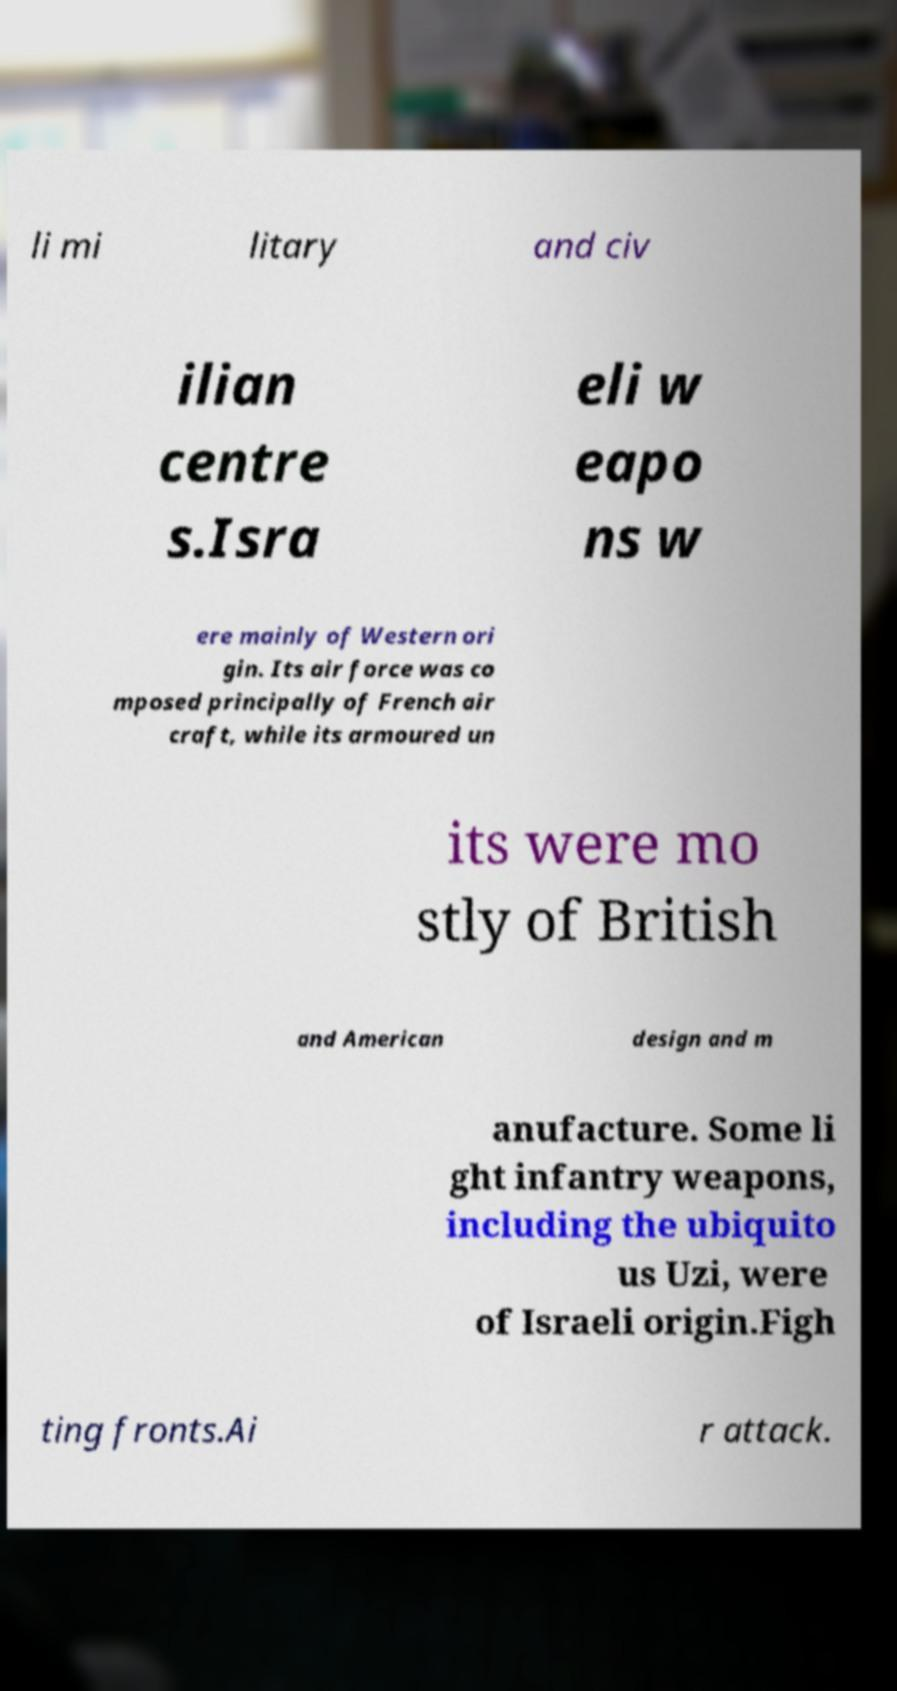Please identify and transcribe the text found in this image. li mi litary and civ ilian centre s.Isra eli w eapo ns w ere mainly of Western ori gin. Its air force was co mposed principally of French air craft, while its armoured un its were mo stly of British and American design and m anufacture. Some li ght infantry weapons, including the ubiquito us Uzi, were of Israeli origin.Figh ting fronts.Ai r attack. 